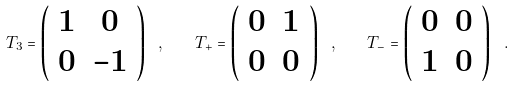<formula> <loc_0><loc_0><loc_500><loc_500>T _ { 3 } = \left ( \begin{array} { c c } 1 & 0 \\ 0 & - 1 \end{array} \right ) \ , \quad T _ { + } = \left ( \begin{array} { c c } 0 & 1 \\ 0 & 0 \end{array} \right ) \ , \quad T _ { - } = \left ( \begin{array} { c c } 0 & 0 \\ 1 & 0 \end{array} \right ) \ .</formula> 